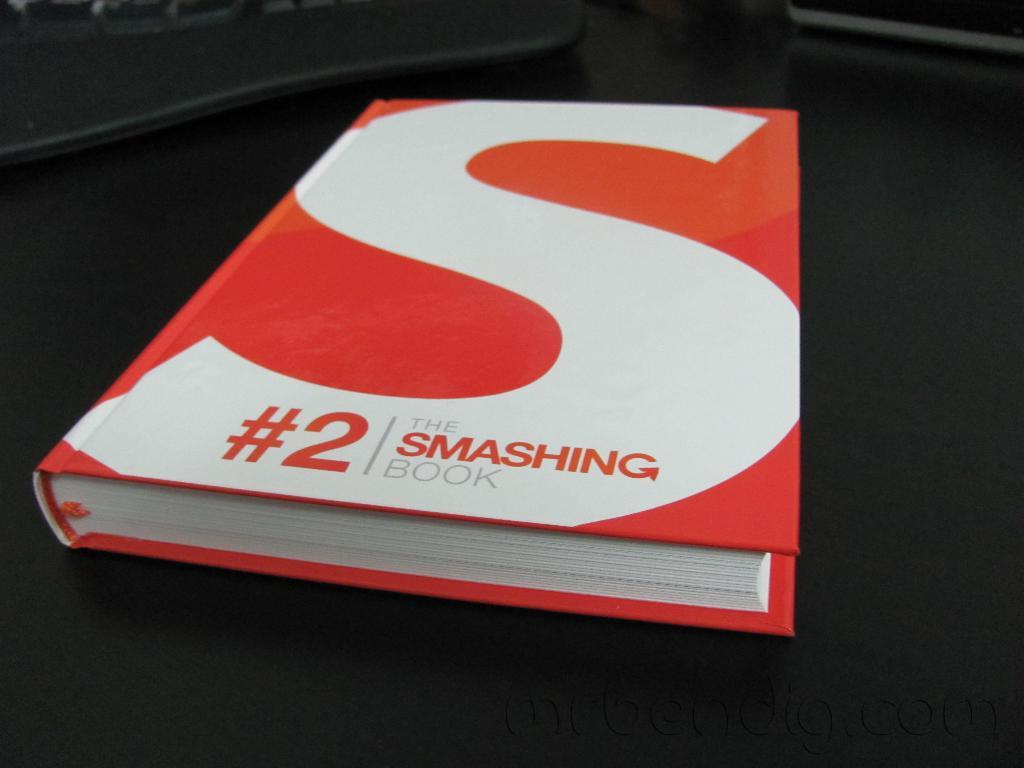<image>
Provide a brief description of the given image. A red and white book called #2 The Smashing Book. 